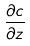Convert formula to latex. <formula><loc_0><loc_0><loc_500><loc_500>\frac { \partial c } { \partial z }</formula> 